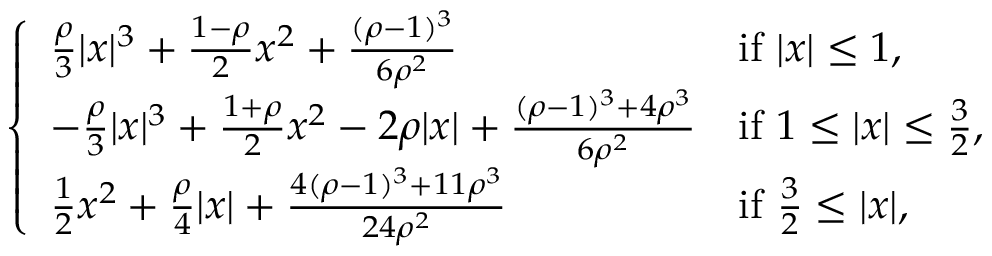<formula> <loc_0><loc_0><loc_500><loc_500>\left \{ \begin{array} { l l } { \frac { \rho } { 3 } | x | ^ { 3 } + \frac { 1 - \rho } { 2 } x ^ { 2 } + \frac { ( \rho - 1 ) ^ { 3 } } { 6 \rho ^ { 2 } } } & { i f | x | \leq 1 , } \\ { - \frac { \rho } { 3 } | x | ^ { 3 } + \frac { 1 + \rho } { 2 } x ^ { 2 } - 2 \rho | x | + \frac { ( \rho - 1 ) ^ { 3 } + 4 \rho ^ { 3 } } { 6 \rho ^ { 2 } } } & { i f 1 \leq | x | \leq \frac { 3 } { 2 } , } \\ { \frac { 1 } { 2 } x ^ { 2 } + \frac { \rho } { 4 } | x | + \frac { 4 ( \rho - 1 ) ^ { 3 } + 1 1 \rho ^ { 3 } } { 2 4 \rho ^ { 2 } } } & { i f \frac { 3 } { 2 } \leq | x | , } \end{array}</formula> 